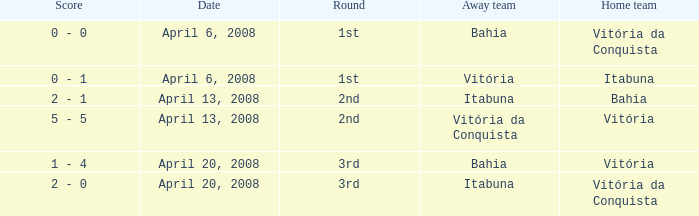Who played as the home team when Vitória was the away team? Itabuna. 